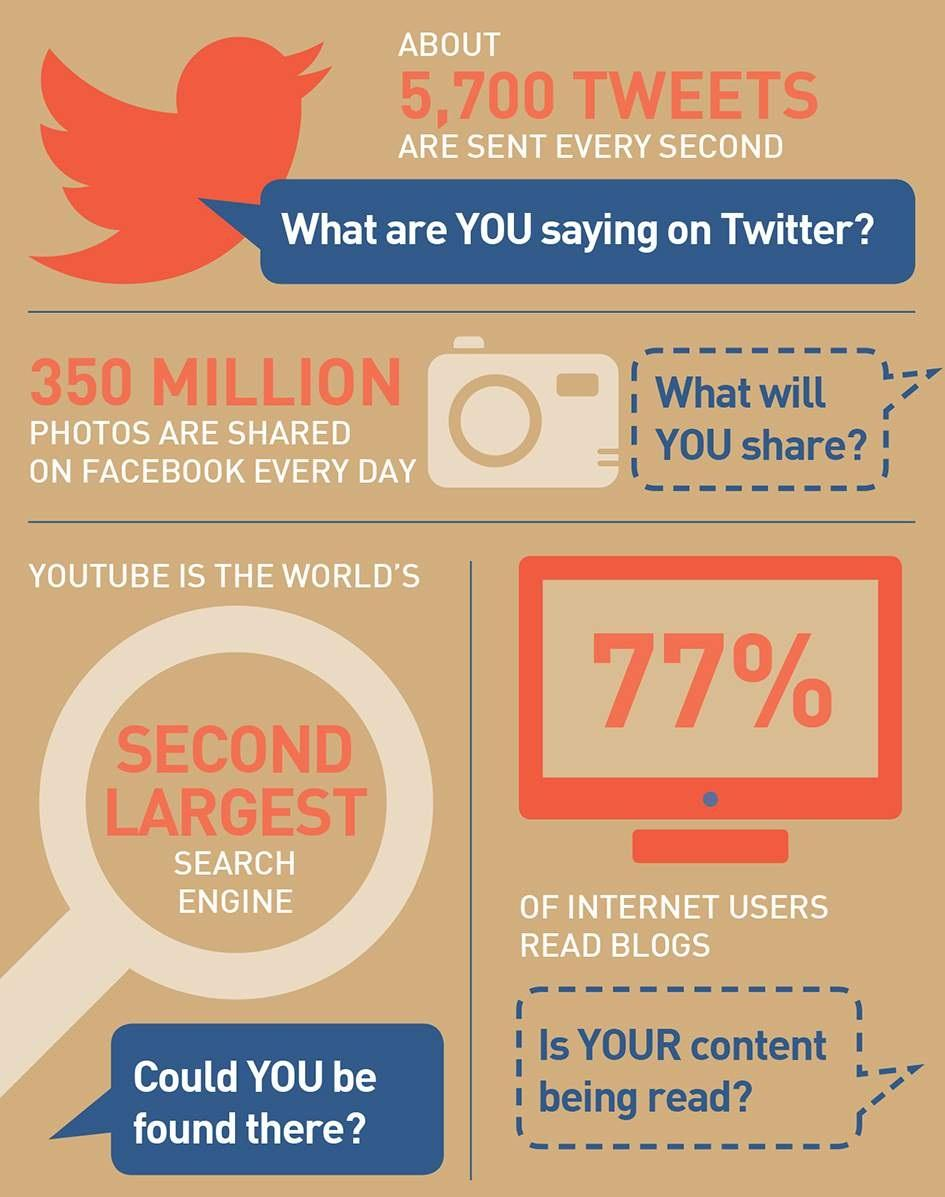List a handful of essential elements in this visual. YouTube is the world's second largest search engine. According to a survey, approximately 23% of internet users do not read blogs. 